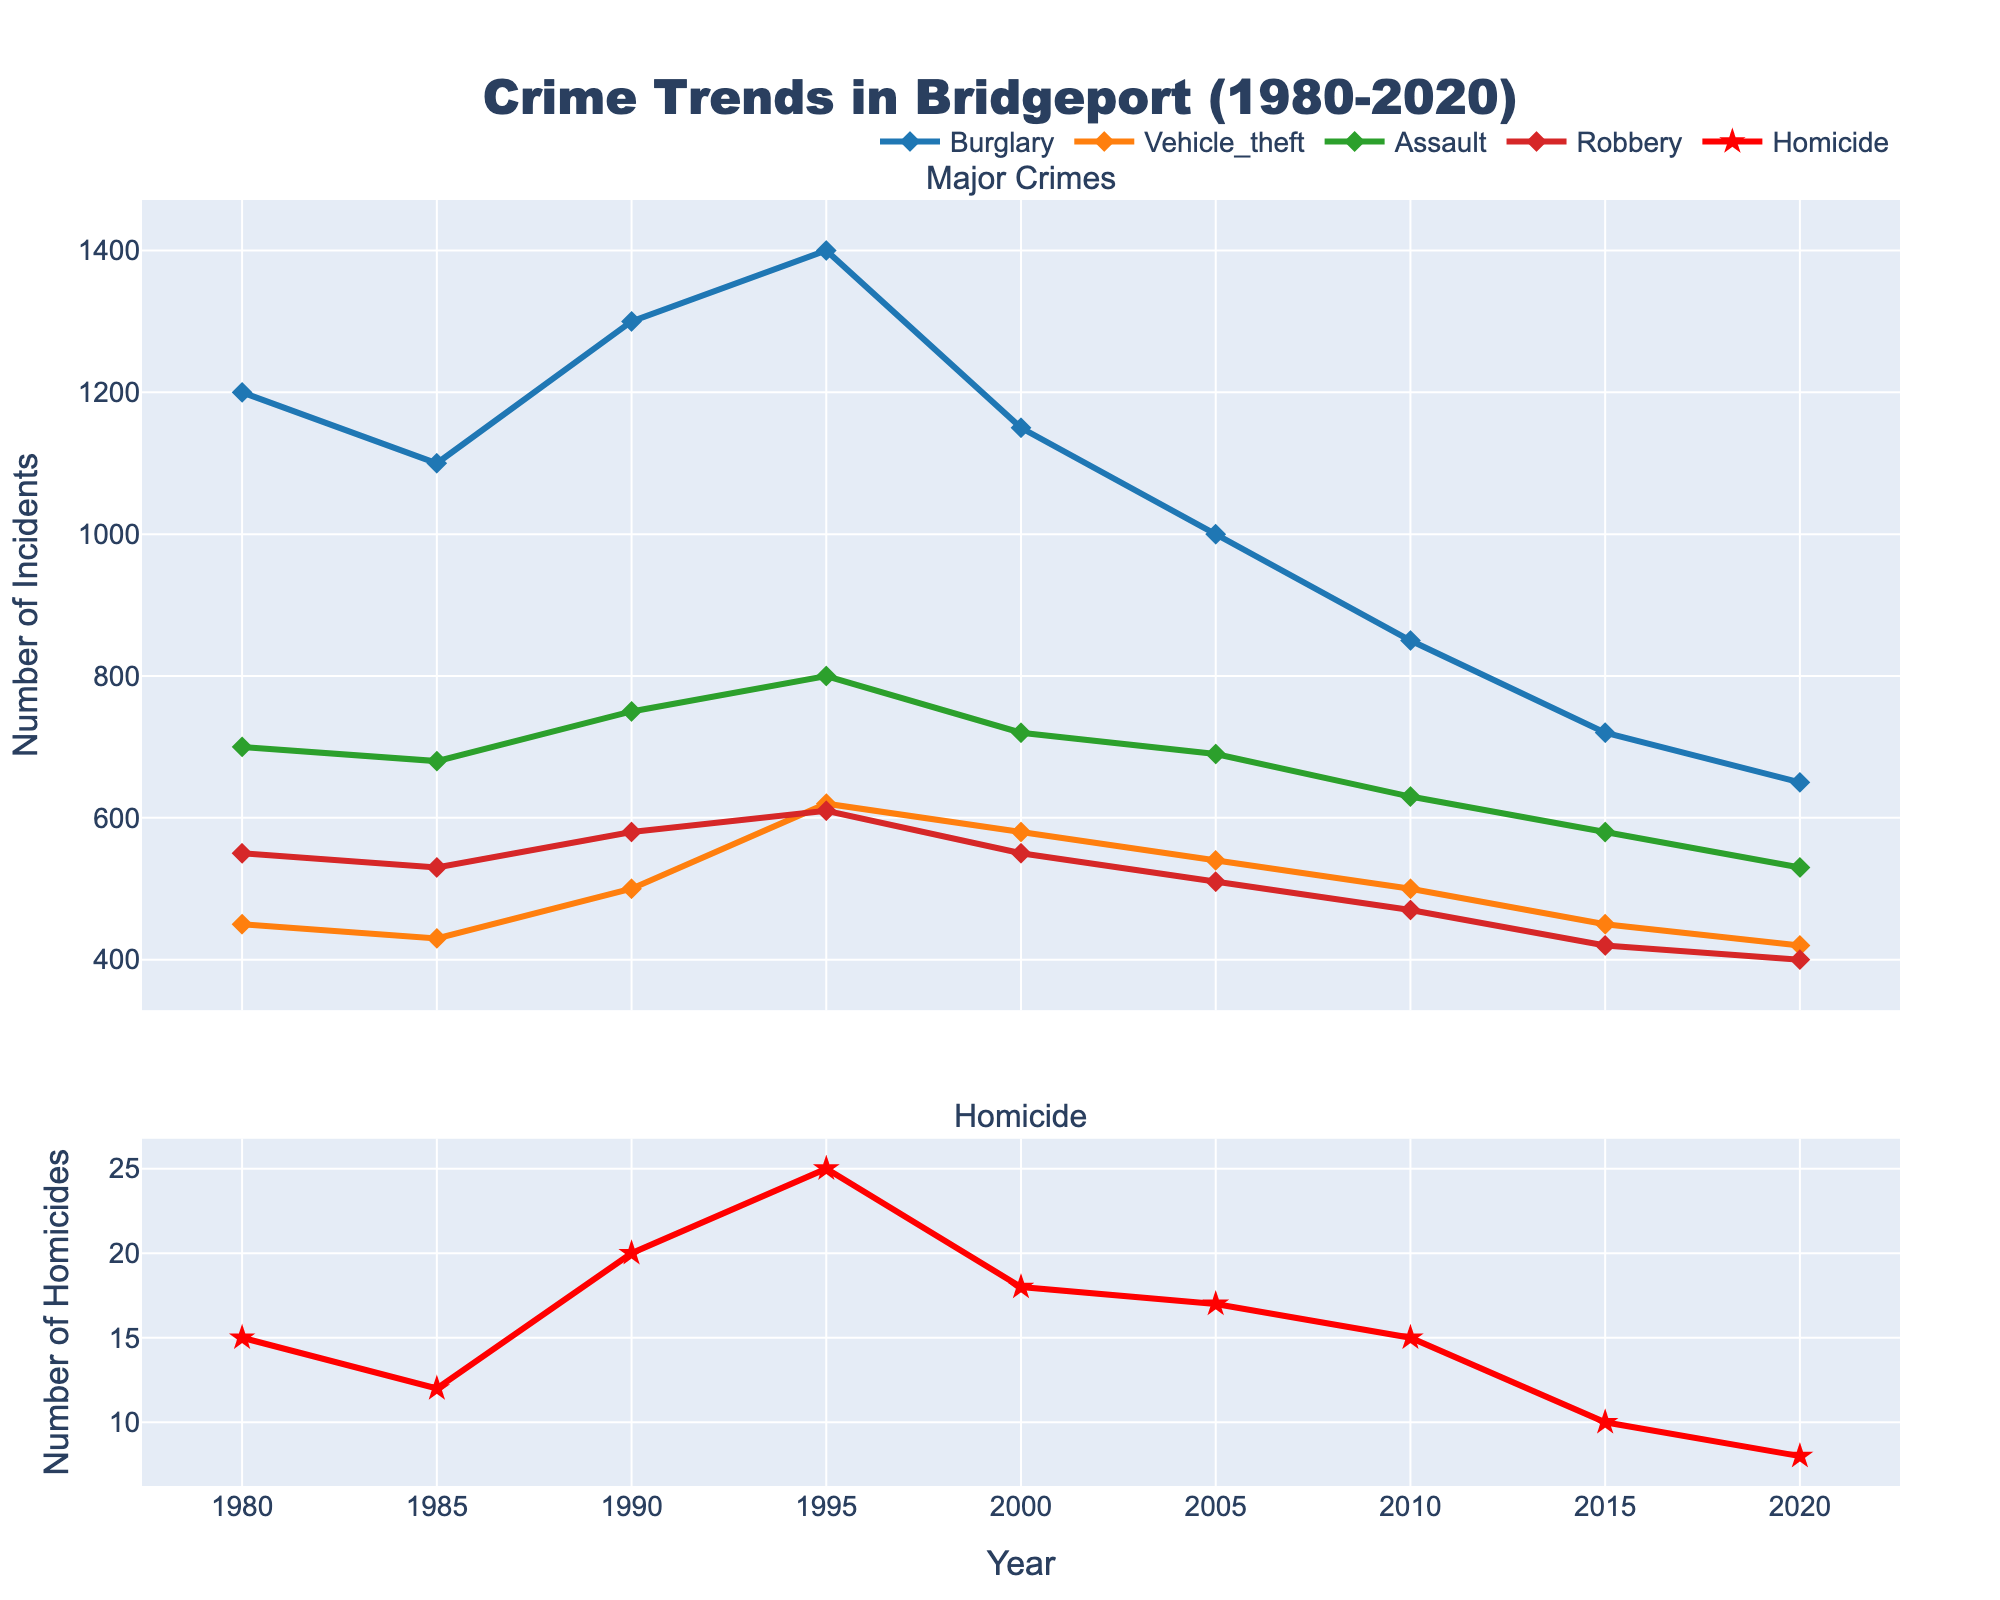What is the title of the plot? The title of the plot is written at the top center of the figure and is "Crime Trends in Bridgeport (1980-2020)".
Answer: "Crime Trends in Bridgeport (1980-2020)" Which type of crime had the highest incident rate in 1995? By examining the year 1995 on the x-axis, you can see that burglary had the highest number of incidents, reaching 1400.
Answer: Burglary How did the number of vehicle theft incidents change from 1980 to 2020? From the figure, vehicle theft incidents decreased from 450 in 1980 to 420 in 2020.
Answer: Decreased What is the color of the line representing homicide? The line representing homicide is colored red, differentiating it from the other crime types.
Answer: Red In which year did assault incidents peak, and what was the value? The peak for assault incidents can be found by looking at the highest point on the assault line, which is in 1995 with a count of 800.
Answer: 1995, 800 What trend can be observed in the rate of robberies from 1980 to 2020? The number of robberies shows an overall decreasing trend, dropping from 550 in 1980 to 400 in 2020.
Answer: Decreasing How many types of crimes are tracked in the major crimes plot? Excluding homicide, four types of crimes are tracked in the major crimes plot: burglary, vehicle theft, assault, and robbery.
Answer: Four Between which two consecutive years was the decrease in burglary incidents the largest? The largest decrease in burglary incidents occurred between 2000 and 2005, dropping from 1150 to 1000, a difference of 150.
Answer: 2000 and 2005 What is the overall trend in homicide rates from 1980 to 2020? The overall trend in homicide rates shows a gradual decline from 15 incidents in 1980 to 8 incidents in 2020.
Answer: Declining Between 2010 and 2020, which crime type showed the largest relative decrease in incidents? Calculating the percentage decrease for each crime type between 2010 and 2020, burglary had the largest relative decrease, dropping from 850 to 650, which is about 23.5%.
Answer: Burglary 